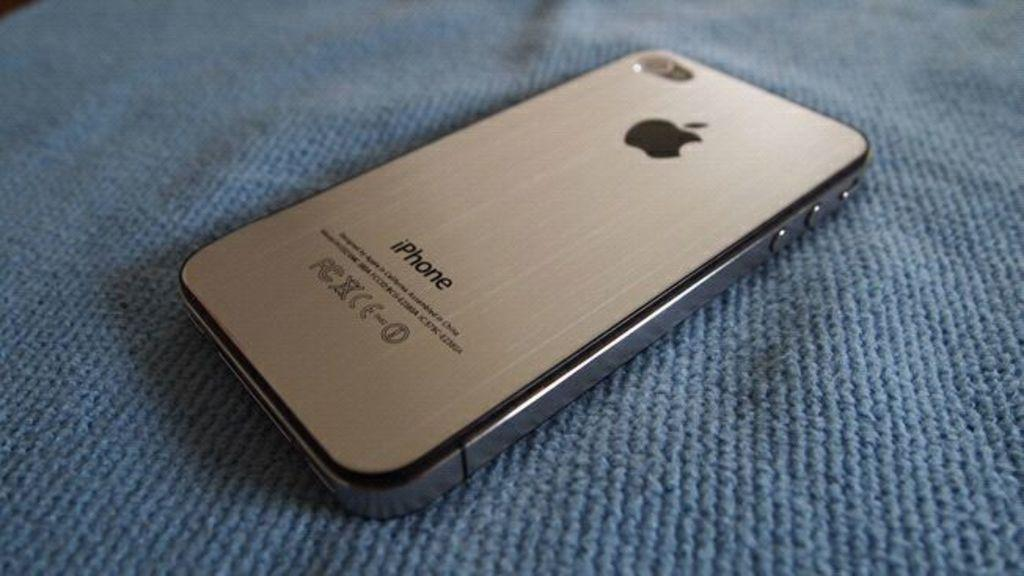Provide a one-sentence caption for the provided image. An iPhone sits face down on a blue cloth. 